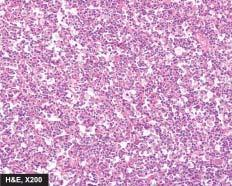does the tumour show uniform cells having high mitotic rate?
Answer the question using a single word or phrase. Yes 